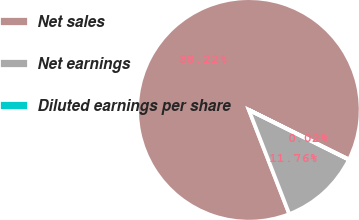<chart> <loc_0><loc_0><loc_500><loc_500><pie_chart><fcel>Net sales<fcel>Net earnings<fcel>Diluted earnings per share<nl><fcel>88.22%<fcel>11.76%<fcel>0.02%<nl></chart> 